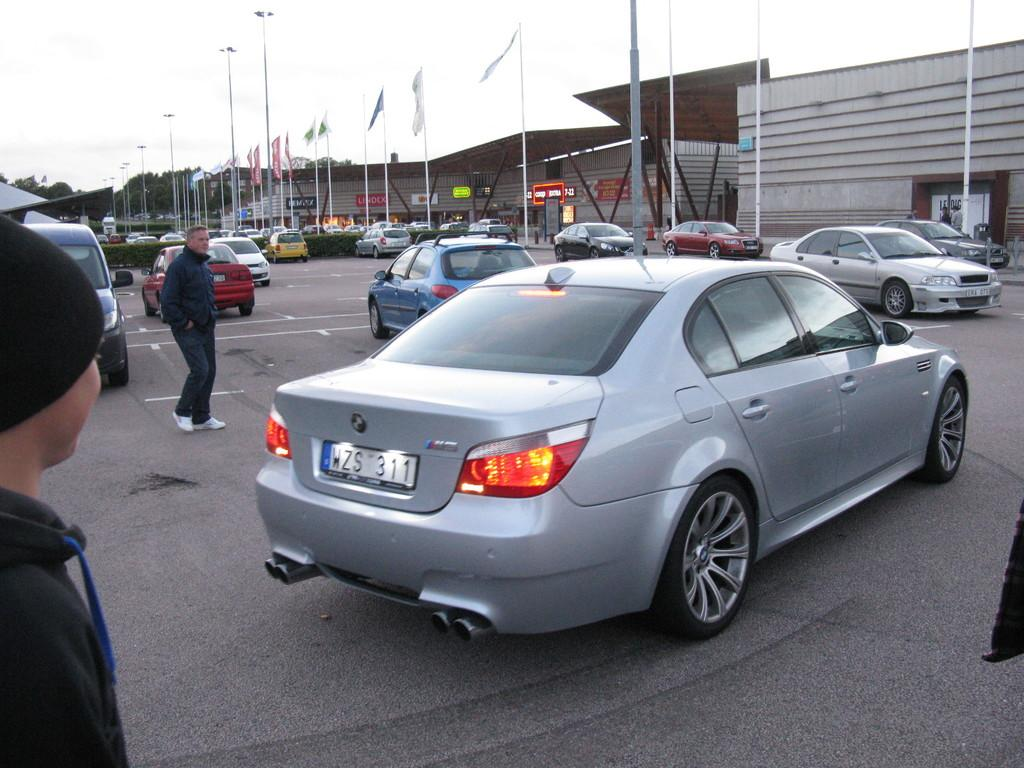<image>
Render a clear and concise summary of the photo. A silver BMW sedan with a tag that reads WZS 311. 